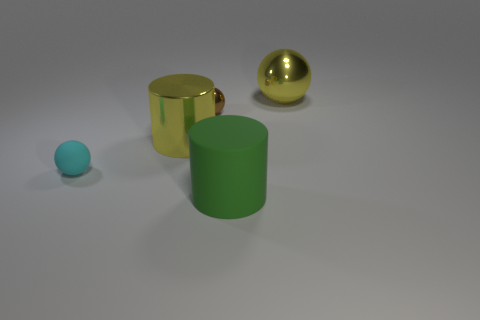Add 2 tiny matte spheres. How many objects exist? 7 Subtract all cylinders. How many objects are left? 3 Add 5 big yellow balls. How many big yellow balls are left? 6 Add 1 large cyan shiny cylinders. How many large cyan shiny cylinders exist? 1 Subtract 0 green cubes. How many objects are left? 5 Subtract all rubber cylinders. Subtract all tiny cyan matte things. How many objects are left? 3 